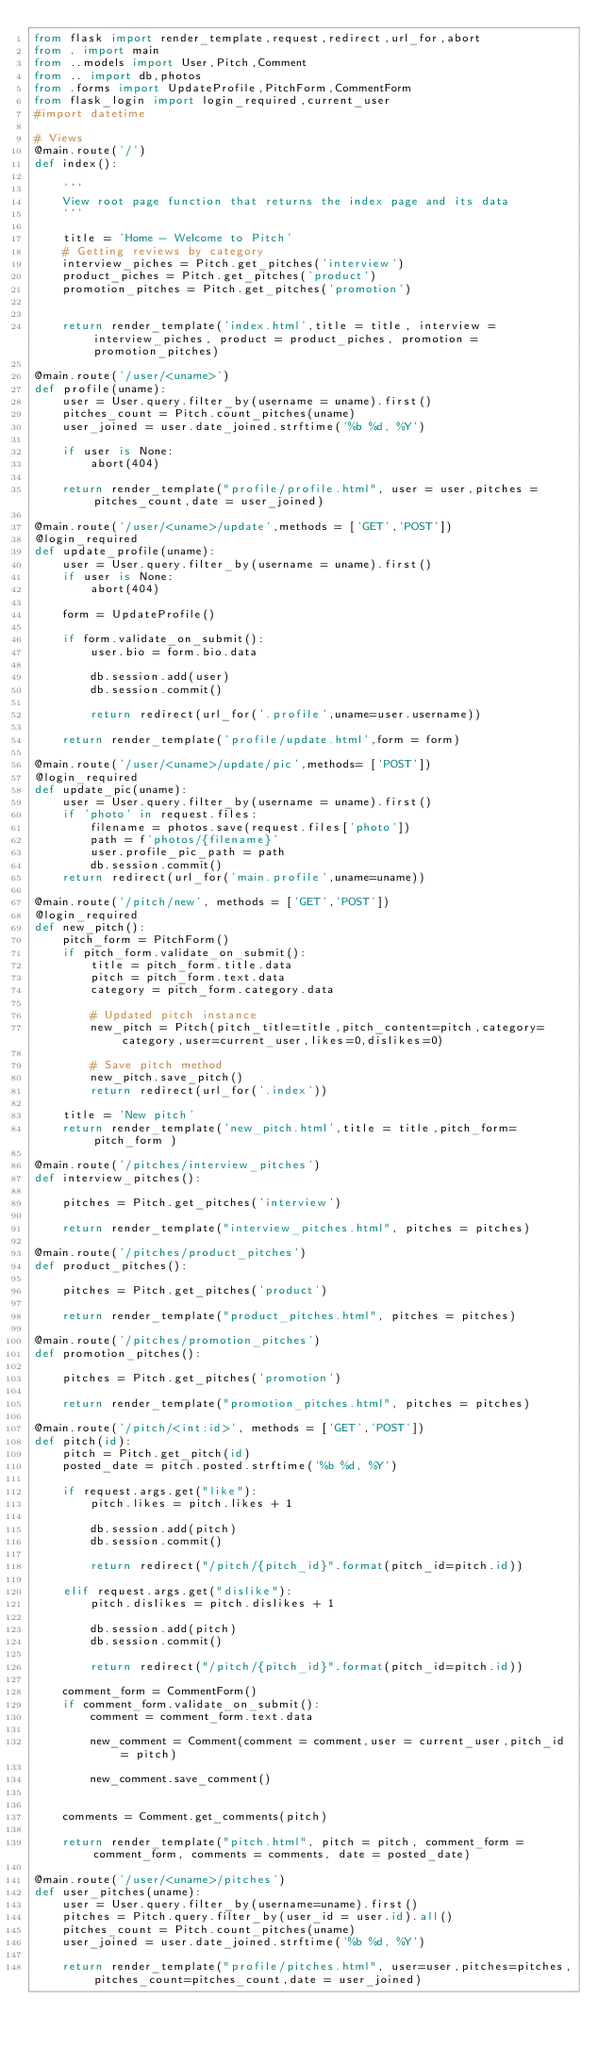Convert code to text. <code><loc_0><loc_0><loc_500><loc_500><_Python_>from flask import render_template,request,redirect,url_for,abort
from . import main
from ..models import User,Pitch,Comment
from .. import db,photos
from .forms import UpdateProfile,PitchForm,CommentForm
from flask_login import login_required,current_user
#import datetime

# Views
@main.route('/')
def index():

    '''
    View root page function that returns the index page and its data
    '''

    title = 'Home - Welcome to Pitch'
    # Getting reviews by category
    interview_piches = Pitch.get_pitches('interview')
    product_piches = Pitch.get_pitches('product')
    promotion_pitches = Pitch.get_pitches('promotion')


    return render_template('index.html',title = title, interview = interview_piches, product = product_piches, promotion = promotion_pitches)

@main.route('/user/<uname>')
def profile(uname):
    user = User.query.filter_by(username = uname).first()
    pitches_count = Pitch.count_pitches(uname)
    user_joined = user.date_joined.strftime('%b %d, %Y')

    if user is None:
        abort(404)

    return render_template("profile/profile.html", user = user,pitches = pitches_count,date = user_joined)

@main.route('/user/<uname>/update',methods = ['GET','POST'])
@login_required
def update_profile(uname):
    user = User.query.filter_by(username = uname).first()
    if user is None:
        abort(404)

    form = UpdateProfile()

    if form.validate_on_submit():
        user.bio = form.bio.data

        db.session.add(user)
        db.session.commit()

        return redirect(url_for('.profile',uname=user.username))

    return render_template('profile/update.html',form = form)

@main.route('/user/<uname>/update/pic',methods= ['POST'])
@login_required
def update_pic(uname):
    user = User.query.filter_by(username = uname).first()
    if 'photo' in request.files:
        filename = photos.save(request.files['photo'])
        path = f'photos/{filename}'
        user.profile_pic_path = path
        db.session.commit()
    return redirect(url_for('main.profile',uname=uname))

@main.route('/pitch/new', methods = ['GET','POST'])
@login_required
def new_pitch():
    pitch_form = PitchForm()
    if pitch_form.validate_on_submit():
        title = pitch_form.title.data
        pitch = pitch_form.text.data
        category = pitch_form.category.data

        # Updated pitch instance
        new_pitch = Pitch(pitch_title=title,pitch_content=pitch,category=category,user=current_user,likes=0,dislikes=0)

        # Save pitch method
        new_pitch.save_pitch()
        return redirect(url_for('.index'))

    title = 'New pitch'
    return render_template('new_pitch.html',title = title,pitch_form=pitch_form )

@main.route('/pitches/interview_pitches')
def interview_pitches():

    pitches = Pitch.get_pitches('interview')

    return render_template("interview_pitches.html", pitches = pitches)

@main.route('/pitches/product_pitches')
def product_pitches():

    pitches = Pitch.get_pitches('product')

    return render_template("product_pitches.html", pitches = pitches)

@main.route('/pitches/promotion_pitches')
def promotion_pitches():

    pitches = Pitch.get_pitches('promotion')

    return render_template("promotion_pitches.html", pitches = pitches)

@main.route('/pitch/<int:id>', methods = ['GET','POST'])
def pitch(id):
    pitch = Pitch.get_pitch(id)
    posted_date = pitch.posted.strftime('%b %d, %Y')

    if request.args.get("like"):
        pitch.likes = pitch.likes + 1

        db.session.add(pitch)
        db.session.commit()

        return redirect("/pitch/{pitch_id}".format(pitch_id=pitch.id))

    elif request.args.get("dislike"):
        pitch.dislikes = pitch.dislikes + 1

        db.session.add(pitch)
        db.session.commit()

        return redirect("/pitch/{pitch_id}".format(pitch_id=pitch.id))

    comment_form = CommentForm()
    if comment_form.validate_on_submit():
        comment = comment_form.text.data

        new_comment = Comment(comment = comment,user = current_user,pitch_id = pitch)

        new_comment.save_comment()


    comments = Comment.get_comments(pitch)

    return render_template("pitch.html", pitch = pitch, comment_form = comment_form, comments = comments, date = posted_date)

@main.route('/user/<uname>/pitches')
def user_pitches(uname):
    user = User.query.filter_by(username=uname).first()
    pitches = Pitch.query.filter_by(user_id = user.id).all()
    pitches_count = Pitch.count_pitches(uname)
    user_joined = user.date_joined.strftime('%b %d, %Y')

    return render_template("profile/pitches.html", user=user,pitches=pitches,pitches_count=pitches_count,date = user_joined)
</code> 